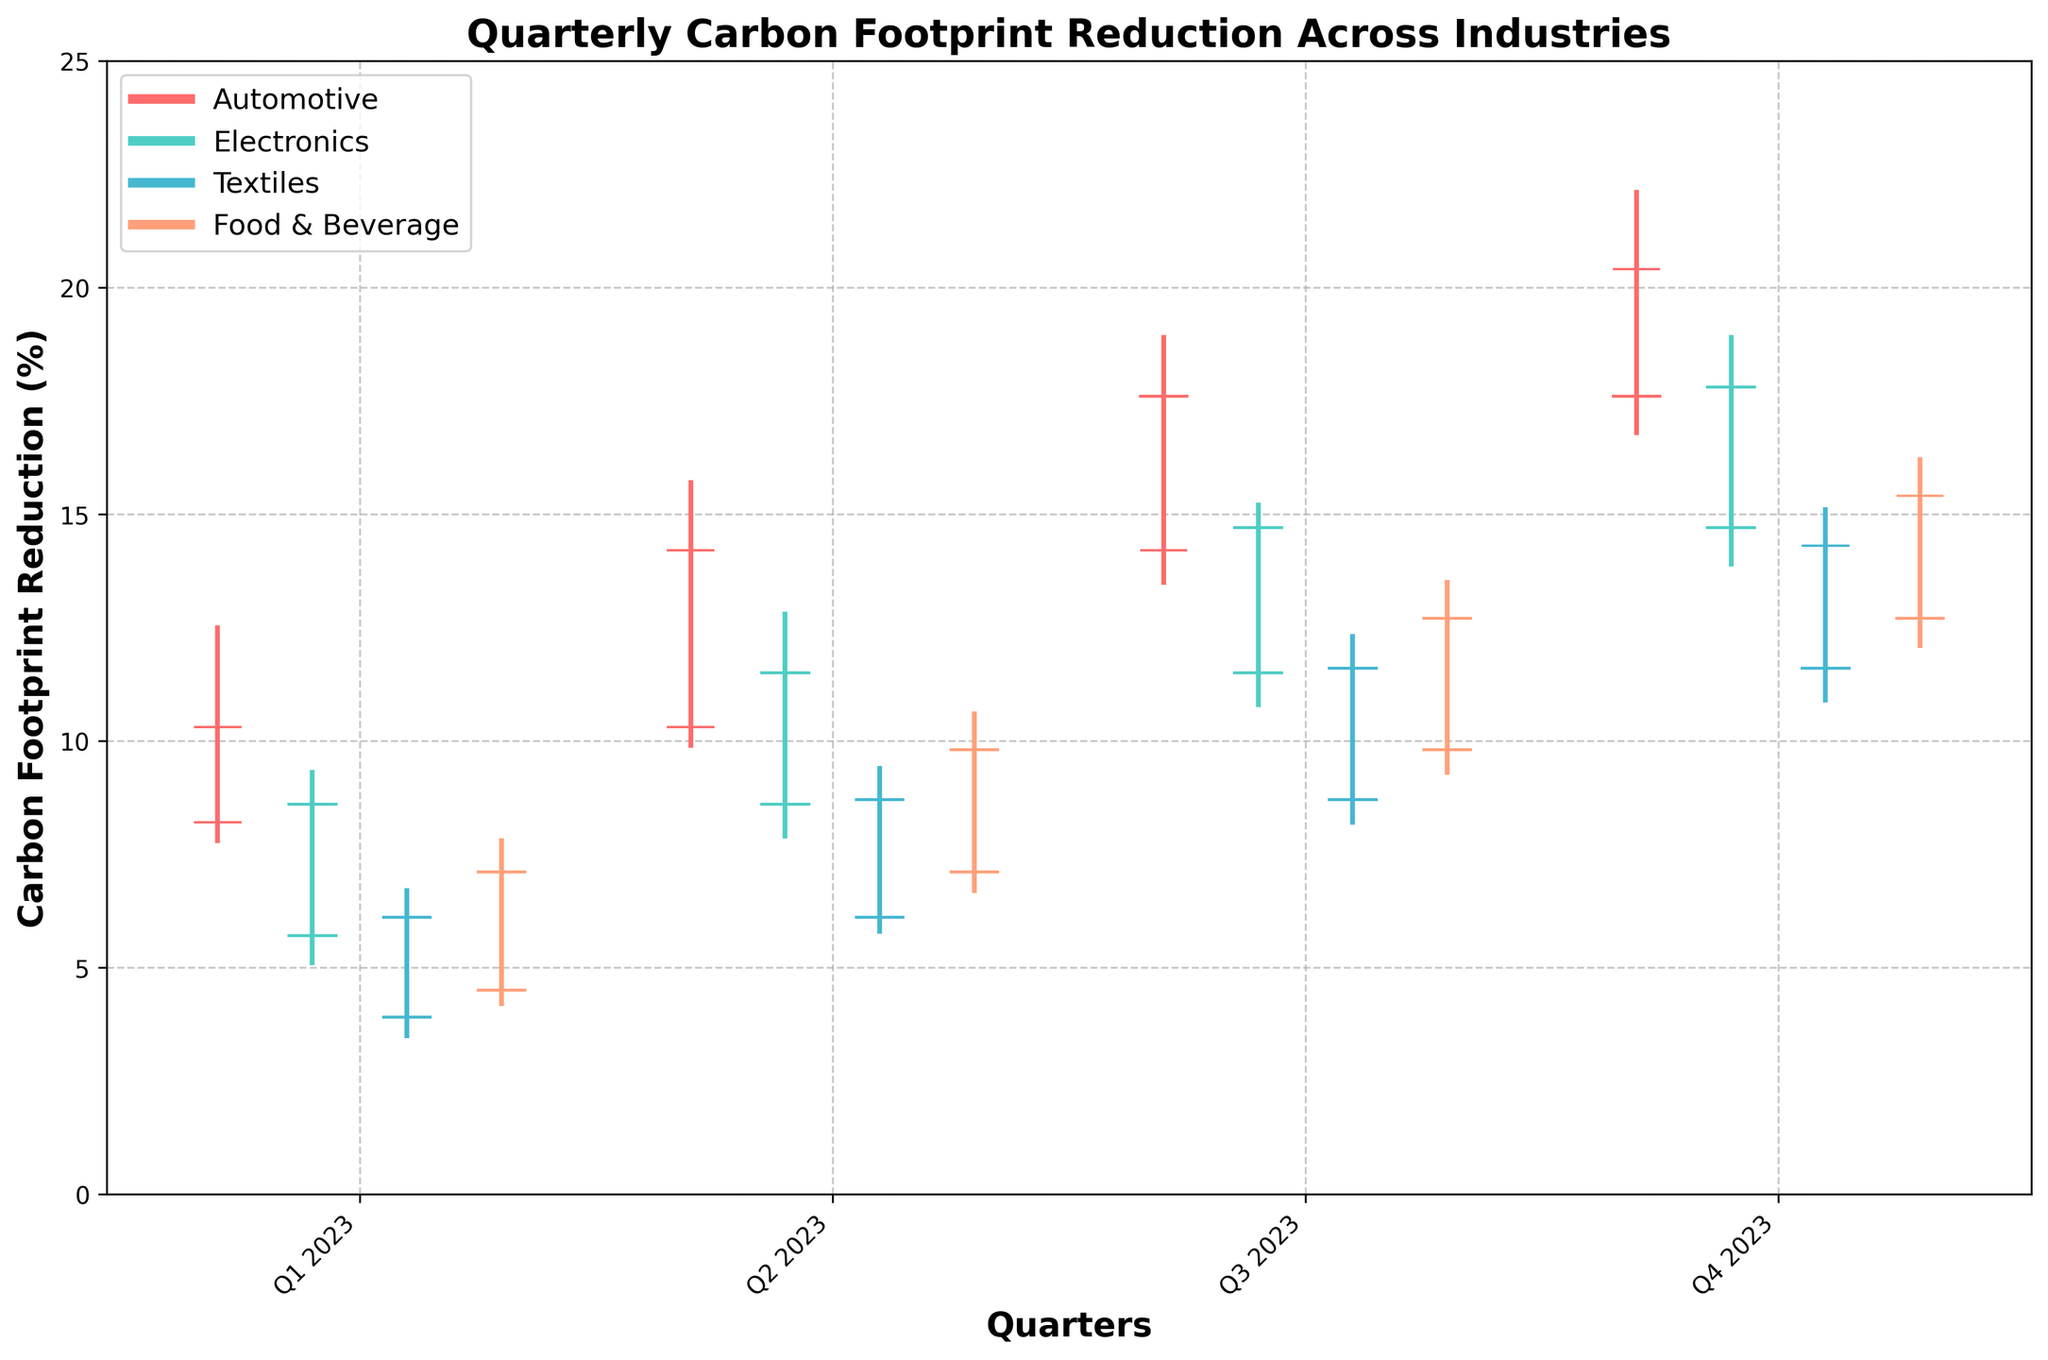Which industry showed the highest carbon footprint reduction in Q3 2023? The plot shows the data for each industry in each quarter. Look at the bar with the highest close value for Q3 2023.
Answer: Automotive Which quarter shows the lowest carbon footprint reduction for the Electronics industry? Review each quarter's values for the Electronics industry on the plot. Identify the bar with the lowest close value.
Answer: Q1 2023 How did the carbon footprint reduction in the Textiles industry change from Q1 2023 to Q4 2023? Compare the close values from Q1 2023 and Q4 2023 for the Textiles industry. The close value in Q1 2023 is 6.1%, and in Q4 2023, it is 14.3%.
Answer: Increased by 8.2% Which industry had the most significant increase in carbon footprint reduction from Q2 2023 to Q3 2023? Calculate the difference in close values between Q2 2023 and Q3 2023 for each industry. The Automotive industry's increase is the highest at 3.4%.
Answer: Automotive Which industry had the least fluctuation in carbon footprint reduction in Q4 2023? Fluctuation is shown by the difference between the high and low values in Q4 2023 for each industry. The Textiles industry has the smallest difference with high 15.1% and low 10.9%.
Answer: Textiles How does the carbon footprint reduction in Q4 2023 for the Food & Beverage industry compare to Q2 2023? Look at the close values for Q2 2023 (9.8%) and Q4 2023 (15.4%) for the Food & Beverage industry.
Answer: Increased by 5.6% Which industry had the highest maximum carbon footprint reduction in any given quarter through 2023? Look at the high values for all quarters across all industries. The Automotive industry has the highest value of 22.1% in Q4 2023.
Answer: Automotive Did the Electronics industry show a steady increase in the carbon footprint reduction through each quarter of 2023? Examine the close values for the Electronics industry from Q1 to Q4 2023. The values continually increase from 8.6% in Q1 to 17.8% in Q4.
Answer: Yes What is the average carbon footprint reduction achieved by the Automotive industry across all quarters in 2023? Sum the close values for the four quarters and divide by 4: (10.3 + 14.2 + 17.6 + 20.4) / 4 = 15.625%.
Answer: 15.625% Which industry had the highest open value in Q2 2023? Review the open values for Q2 2023 across all industries. The highest open value is 10.3% for the Automotive industry.
Answer: Automotive 